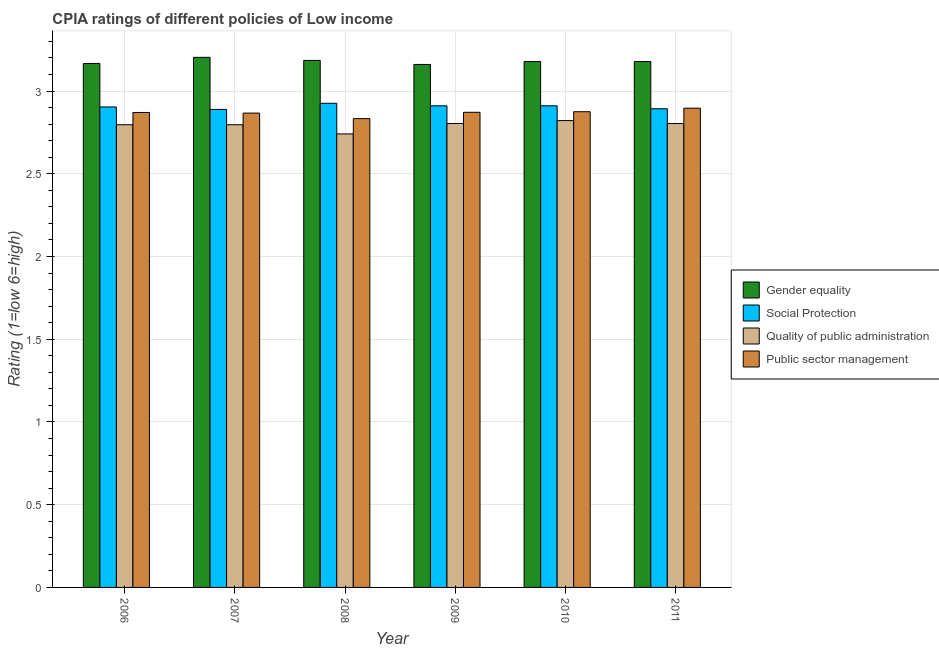Are the number of bars per tick equal to the number of legend labels?
Keep it short and to the point. Yes. How many bars are there on the 6th tick from the right?
Provide a succinct answer. 4. What is the cpia rating of public sector management in 2007?
Offer a terse response. 2.87. Across all years, what is the maximum cpia rating of social protection?
Your answer should be compact. 2.93. Across all years, what is the minimum cpia rating of quality of public administration?
Offer a very short reply. 2.74. In which year was the cpia rating of gender equality minimum?
Offer a terse response. 2009. What is the total cpia rating of quality of public administration in the graph?
Your answer should be very brief. 16.76. What is the difference between the cpia rating of social protection in 2008 and that in 2010?
Make the answer very short. 0.02. What is the difference between the cpia rating of gender equality in 2008 and the cpia rating of quality of public administration in 2009?
Your answer should be compact. 0.02. What is the average cpia rating of public sector management per year?
Your response must be concise. 2.87. In the year 2010, what is the difference between the cpia rating of gender equality and cpia rating of quality of public administration?
Offer a terse response. 0. What is the ratio of the cpia rating of social protection in 2008 to that in 2009?
Keep it short and to the point. 1.01. What is the difference between the highest and the second highest cpia rating of quality of public administration?
Provide a short and direct response. 0.02. What is the difference between the highest and the lowest cpia rating of quality of public administration?
Your response must be concise. 0.08. Is the sum of the cpia rating of gender equality in 2007 and 2009 greater than the maximum cpia rating of quality of public administration across all years?
Provide a succinct answer. Yes. What does the 1st bar from the left in 2010 represents?
Give a very brief answer. Gender equality. What does the 4th bar from the right in 2009 represents?
Make the answer very short. Gender equality. Is it the case that in every year, the sum of the cpia rating of gender equality and cpia rating of social protection is greater than the cpia rating of quality of public administration?
Offer a terse response. Yes. How many years are there in the graph?
Give a very brief answer. 6. Are the values on the major ticks of Y-axis written in scientific E-notation?
Ensure brevity in your answer.  No. How are the legend labels stacked?
Give a very brief answer. Vertical. What is the title of the graph?
Give a very brief answer. CPIA ratings of different policies of Low income. What is the label or title of the X-axis?
Your answer should be very brief. Year. What is the Rating (1=low 6=high) of Gender equality in 2006?
Make the answer very short. 3.17. What is the Rating (1=low 6=high) of Social Protection in 2006?
Keep it short and to the point. 2.9. What is the Rating (1=low 6=high) of Quality of public administration in 2006?
Keep it short and to the point. 2.8. What is the Rating (1=low 6=high) of Public sector management in 2006?
Your answer should be very brief. 2.87. What is the Rating (1=low 6=high) of Gender equality in 2007?
Give a very brief answer. 3.2. What is the Rating (1=low 6=high) of Social Protection in 2007?
Ensure brevity in your answer.  2.89. What is the Rating (1=low 6=high) of Quality of public administration in 2007?
Provide a succinct answer. 2.8. What is the Rating (1=low 6=high) in Public sector management in 2007?
Keep it short and to the point. 2.87. What is the Rating (1=low 6=high) in Gender equality in 2008?
Offer a terse response. 3.19. What is the Rating (1=low 6=high) of Social Protection in 2008?
Offer a terse response. 2.93. What is the Rating (1=low 6=high) of Quality of public administration in 2008?
Your answer should be very brief. 2.74. What is the Rating (1=low 6=high) in Public sector management in 2008?
Keep it short and to the point. 2.83. What is the Rating (1=low 6=high) in Gender equality in 2009?
Make the answer very short. 3.16. What is the Rating (1=low 6=high) of Social Protection in 2009?
Offer a terse response. 2.91. What is the Rating (1=low 6=high) in Quality of public administration in 2009?
Your answer should be compact. 2.8. What is the Rating (1=low 6=high) of Public sector management in 2009?
Offer a terse response. 2.87. What is the Rating (1=low 6=high) in Gender equality in 2010?
Your response must be concise. 3.18. What is the Rating (1=low 6=high) in Social Protection in 2010?
Offer a terse response. 2.91. What is the Rating (1=low 6=high) in Quality of public administration in 2010?
Make the answer very short. 2.82. What is the Rating (1=low 6=high) of Public sector management in 2010?
Your response must be concise. 2.88. What is the Rating (1=low 6=high) in Gender equality in 2011?
Your answer should be very brief. 3.18. What is the Rating (1=low 6=high) of Social Protection in 2011?
Your answer should be very brief. 2.89. What is the Rating (1=low 6=high) of Quality of public administration in 2011?
Provide a short and direct response. 2.8. What is the Rating (1=low 6=high) of Public sector management in 2011?
Make the answer very short. 2.9. Across all years, what is the maximum Rating (1=low 6=high) of Gender equality?
Ensure brevity in your answer.  3.2. Across all years, what is the maximum Rating (1=low 6=high) in Social Protection?
Make the answer very short. 2.93. Across all years, what is the maximum Rating (1=low 6=high) in Quality of public administration?
Offer a very short reply. 2.82. Across all years, what is the maximum Rating (1=low 6=high) in Public sector management?
Offer a terse response. 2.9. Across all years, what is the minimum Rating (1=low 6=high) in Gender equality?
Make the answer very short. 3.16. Across all years, what is the minimum Rating (1=low 6=high) of Social Protection?
Your answer should be compact. 2.89. Across all years, what is the minimum Rating (1=low 6=high) of Quality of public administration?
Keep it short and to the point. 2.74. Across all years, what is the minimum Rating (1=low 6=high) in Public sector management?
Give a very brief answer. 2.83. What is the total Rating (1=low 6=high) in Gender equality in the graph?
Your answer should be compact. 19.07. What is the total Rating (1=low 6=high) of Social Protection in the graph?
Your answer should be compact. 17.43. What is the total Rating (1=low 6=high) of Quality of public administration in the graph?
Provide a short and direct response. 16.76. What is the total Rating (1=low 6=high) of Public sector management in the graph?
Offer a very short reply. 17.21. What is the difference between the Rating (1=low 6=high) in Gender equality in 2006 and that in 2007?
Ensure brevity in your answer.  -0.04. What is the difference between the Rating (1=low 6=high) in Social Protection in 2006 and that in 2007?
Offer a terse response. 0.01. What is the difference between the Rating (1=low 6=high) in Public sector management in 2006 and that in 2007?
Your answer should be compact. 0. What is the difference between the Rating (1=low 6=high) of Gender equality in 2006 and that in 2008?
Your answer should be compact. -0.02. What is the difference between the Rating (1=low 6=high) in Social Protection in 2006 and that in 2008?
Keep it short and to the point. -0.02. What is the difference between the Rating (1=low 6=high) in Quality of public administration in 2006 and that in 2008?
Offer a very short reply. 0.06. What is the difference between the Rating (1=low 6=high) in Public sector management in 2006 and that in 2008?
Offer a terse response. 0.04. What is the difference between the Rating (1=low 6=high) of Gender equality in 2006 and that in 2009?
Keep it short and to the point. 0.01. What is the difference between the Rating (1=low 6=high) of Social Protection in 2006 and that in 2009?
Offer a very short reply. -0.01. What is the difference between the Rating (1=low 6=high) in Quality of public administration in 2006 and that in 2009?
Ensure brevity in your answer.  -0.01. What is the difference between the Rating (1=low 6=high) in Public sector management in 2006 and that in 2009?
Your answer should be compact. -0. What is the difference between the Rating (1=low 6=high) of Gender equality in 2006 and that in 2010?
Provide a succinct answer. -0.01. What is the difference between the Rating (1=low 6=high) in Social Protection in 2006 and that in 2010?
Ensure brevity in your answer.  -0.01. What is the difference between the Rating (1=low 6=high) in Quality of public administration in 2006 and that in 2010?
Your answer should be compact. -0.03. What is the difference between the Rating (1=low 6=high) in Public sector management in 2006 and that in 2010?
Make the answer very short. -0. What is the difference between the Rating (1=low 6=high) in Gender equality in 2006 and that in 2011?
Your response must be concise. -0.01. What is the difference between the Rating (1=low 6=high) of Social Protection in 2006 and that in 2011?
Keep it short and to the point. 0.01. What is the difference between the Rating (1=low 6=high) of Quality of public administration in 2006 and that in 2011?
Offer a very short reply. -0.01. What is the difference between the Rating (1=low 6=high) in Public sector management in 2006 and that in 2011?
Keep it short and to the point. -0.03. What is the difference between the Rating (1=low 6=high) of Gender equality in 2007 and that in 2008?
Provide a short and direct response. 0.02. What is the difference between the Rating (1=low 6=high) of Social Protection in 2007 and that in 2008?
Offer a terse response. -0.04. What is the difference between the Rating (1=low 6=high) of Quality of public administration in 2007 and that in 2008?
Your response must be concise. 0.06. What is the difference between the Rating (1=low 6=high) of Public sector management in 2007 and that in 2008?
Your answer should be compact. 0.03. What is the difference between the Rating (1=low 6=high) of Gender equality in 2007 and that in 2009?
Ensure brevity in your answer.  0.04. What is the difference between the Rating (1=low 6=high) in Social Protection in 2007 and that in 2009?
Your answer should be compact. -0.02. What is the difference between the Rating (1=low 6=high) in Quality of public administration in 2007 and that in 2009?
Offer a terse response. -0.01. What is the difference between the Rating (1=low 6=high) in Public sector management in 2007 and that in 2009?
Offer a terse response. -0. What is the difference between the Rating (1=low 6=high) in Gender equality in 2007 and that in 2010?
Give a very brief answer. 0.03. What is the difference between the Rating (1=low 6=high) of Social Protection in 2007 and that in 2010?
Make the answer very short. -0.02. What is the difference between the Rating (1=low 6=high) in Quality of public administration in 2007 and that in 2010?
Offer a very short reply. -0.03. What is the difference between the Rating (1=low 6=high) in Public sector management in 2007 and that in 2010?
Make the answer very short. -0.01. What is the difference between the Rating (1=low 6=high) in Gender equality in 2007 and that in 2011?
Provide a succinct answer. 0.03. What is the difference between the Rating (1=low 6=high) in Social Protection in 2007 and that in 2011?
Your answer should be compact. -0. What is the difference between the Rating (1=low 6=high) of Quality of public administration in 2007 and that in 2011?
Give a very brief answer. -0.01. What is the difference between the Rating (1=low 6=high) of Public sector management in 2007 and that in 2011?
Provide a succinct answer. -0.03. What is the difference between the Rating (1=low 6=high) in Gender equality in 2008 and that in 2009?
Offer a very short reply. 0.02. What is the difference between the Rating (1=low 6=high) of Social Protection in 2008 and that in 2009?
Your answer should be very brief. 0.02. What is the difference between the Rating (1=low 6=high) in Quality of public administration in 2008 and that in 2009?
Make the answer very short. -0.06. What is the difference between the Rating (1=low 6=high) of Public sector management in 2008 and that in 2009?
Provide a short and direct response. -0.04. What is the difference between the Rating (1=low 6=high) in Gender equality in 2008 and that in 2010?
Make the answer very short. 0.01. What is the difference between the Rating (1=low 6=high) in Social Protection in 2008 and that in 2010?
Give a very brief answer. 0.02. What is the difference between the Rating (1=low 6=high) of Quality of public administration in 2008 and that in 2010?
Your answer should be compact. -0.08. What is the difference between the Rating (1=low 6=high) in Public sector management in 2008 and that in 2010?
Your answer should be compact. -0.04. What is the difference between the Rating (1=low 6=high) in Gender equality in 2008 and that in 2011?
Ensure brevity in your answer.  0.01. What is the difference between the Rating (1=low 6=high) in Social Protection in 2008 and that in 2011?
Your answer should be compact. 0.03. What is the difference between the Rating (1=low 6=high) of Quality of public administration in 2008 and that in 2011?
Your answer should be compact. -0.06. What is the difference between the Rating (1=low 6=high) in Public sector management in 2008 and that in 2011?
Make the answer very short. -0.06. What is the difference between the Rating (1=low 6=high) of Gender equality in 2009 and that in 2010?
Give a very brief answer. -0.02. What is the difference between the Rating (1=low 6=high) of Social Protection in 2009 and that in 2010?
Your response must be concise. 0. What is the difference between the Rating (1=low 6=high) of Quality of public administration in 2009 and that in 2010?
Offer a terse response. -0.02. What is the difference between the Rating (1=low 6=high) of Public sector management in 2009 and that in 2010?
Make the answer very short. -0. What is the difference between the Rating (1=low 6=high) of Gender equality in 2009 and that in 2011?
Your answer should be compact. -0.02. What is the difference between the Rating (1=low 6=high) in Social Protection in 2009 and that in 2011?
Your response must be concise. 0.02. What is the difference between the Rating (1=low 6=high) of Quality of public administration in 2009 and that in 2011?
Your response must be concise. 0. What is the difference between the Rating (1=low 6=high) of Public sector management in 2009 and that in 2011?
Make the answer very short. -0.03. What is the difference between the Rating (1=low 6=high) of Social Protection in 2010 and that in 2011?
Provide a succinct answer. 0.02. What is the difference between the Rating (1=low 6=high) of Quality of public administration in 2010 and that in 2011?
Ensure brevity in your answer.  0.02. What is the difference between the Rating (1=low 6=high) in Public sector management in 2010 and that in 2011?
Offer a terse response. -0.02. What is the difference between the Rating (1=low 6=high) in Gender equality in 2006 and the Rating (1=low 6=high) in Social Protection in 2007?
Provide a succinct answer. 0.28. What is the difference between the Rating (1=low 6=high) in Gender equality in 2006 and the Rating (1=low 6=high) in Quality of public administration in 2007?
Your answer should be very brief. 0.37. What is the difference between the Rating (1=low 6=high) of Gender equality in 2006 and the Rating (1=low 6=high) of Public sector management in 2007?
Ensure brevity in your answer.  0.3. What is the difference between the Rating (1=low 6=high) in Social Protection in 2006 and the Rating (1=low 6=high) in Quality of public administration in 2007?
Ensure brevity in your answer.  0.11. What is the difference between the Rating (1=low 6=high) of Social Protection in 2006 and the Rating (1=low 6=high) of Public sector management in 2007?
Give a very brief answer. 0.04. What is the difference between the Rating (1=low 6=high) of Quality of public administration in 2006 and the Rating (1=low 6=high) of Public sector management in 2007?
Provide a succinct answer. -0.07. What is the difference between the Rating (1=low 6=high) of Gender equality in 2006 and the Rating (1=low 6=high) of Social Protection in 2008?
Offer a very short reply. 0.24. What is the difference between the Rating (1=low 6=high) in Gender equality in 2006 and the Rating (1=low 6=high) in Quality of public administration in 2008?
Keep it short and to the point. 0.43. What is the difference between the Rating (1=low 6=high) of Gender equality in 2006 and the Rating (1=low 6=high) of Public sector management in 2008?
Make the answer very short. 0.33. What is the difference between the Rating (1=low 6=high) in Social Protection in 2006 and the Rating (1=low 6=high) in Quality of public administration in 2008?
Offer a terse response. 0.16. What is the difference between the Rating (1=low 6=high) in Social Protection in 2006 and the Rating (1=low 6=high) in Public sector management in 2008?
Offer a terse response. 0.07. What is the difference between the Rating (1=low 6=high) in Quality of public administration in 2006 and the Rating (1=low 6=high) in Public sector management in 2008?
Make the answer very short. -0.04. What is the difference between the Rating (1=low 6=high) of Gender equality in 2006 and the Rating (1=low 6=high) of Social Protection in 2009?
Your answer should be very brief. 0.26. What is the difference between the Rating (1=low 6=high) in Gender equality in 2006 and the Rating (1=low 6=high) in Quality of public administration in 2009?
Keep it short and to the point. 0.36. What is the difference between the Rating (1=low 6=high) of Gender equality in 2006 and the Rating (1=low 6=high) of Public sector management in 2009?
Keep it short and to the point. 0.3. What is the difference between the Rating (1=low 6=high) in Social Protection in 2006 and the Rating (1=low 6=high) in Quality of public administration in 2009?
Give a very brief answer. 0.1. What is the difference between the Rating (1=low 6=high) of Social Protection in 2006 and the Rating (1=low 6=high) of Public sector management in 2009?
Ensure brevity in your answer.  0.03. What is the difference between the Rating (1=low 6=high) of Quality of public administration in 2006 and the Rating (1=low 6=high) of Public sector management in 2009?
Provide a short and direct response. -0.08. What is the difference between the Rating (1=low 6=high) of Gender equality in 2006 and the Rating (1=low 6=high) of Social Protection in 2010?
Your response must be concise. 0.26. What is the difference between the Rating (1=low 6=high) of Gender equality in 2006 and the Rating (1=low 6=high) of Quality of public administration in 2010?
Ensure brevity in your answer.  0.35. What is the difference between the Rating (1=low 6=high) of Gender equality in 2006 and the Rating (1=low 6=high) of Public sector management in 2010?
Make the answer very short. 0.29. What is the difference between the Rating (1=low 6=high) of Social Protection in 2006 and the Rating (1=low 6=high) of Quality of public administration in 2010?
Offer a terse response. 0.08. What is the difference between the Rating (1=low 6=high) in Social Protection in 2006 and the Rating (1=low 6=high) in Public sector management in 2010?
Your response must be concise. 0.03. What is the difference between the Rating (1=low 6=high) in Quality of public administration in 2006 and the Rating (1=low 6=high) in Public sector management in 2010?
Make the answer very short. -0.08. What is the difference between the Rating (1=low 6=high) of Gender equality in 2006 and the Rating (1=low 6=high) of Social Protection in 2011?
Ensure brevity in your answer.  0.27. What is the difference between the Rating (1=low 6=high) in Gender equality in 2006 and the Rating (1=low 6=high) in Quality of public administration in 2011?
Ensure brevity in your answer.  0.36. What is the difference between the Rating (1=low 6=high) in Gender equality in 2006 and the Rating (1=low 6=high) in Public sector management in 2011?
Your answer should be compact. 0.27. What is the difference between the Rating (1=low 6=high) in Social Protection in 2006 and the Rating (1=low 6=high) in Quality of public administration in 2011?
Your response must be concise. 0.1. What is the difference between the Rating (1=low 6=high) in Social Protection in 2006 and the Rating (1=low 6=high) in Public sector management in 2011?
Provide a succinct answer. 0.01. What is the difference between the Rating (1=low 6=high) of Quality of public administration in 2006 and the Rating (1=low 6=high) of Public sector management in 2011?
Your answer should be very brief. -0.1. What is the difference between the Rating (1=low 6=high) in Gender equality in 2007 and the Rating (1=low 6=high) in Social Protection in 2008?
Offer a very short reply. 0.28. What is the difference between the Rating (1=low 6=high) of Gender equality in 2007 and the Rating (1=low 6=high) of Quality of public administration in 2008?
Provide a succinct answer. 0.46. What is the difference between the Rating (1=low 6=high) of Gender equality in 2007 and the Rating (1=low 6=high) of Public sector management in 2008?
Provide a short and direct response. 0.37. What is the difference between the Rating (1=low 6=high) in Social Protection in 2007 and the Rating (1=low 6=high) in Quality of public administration in 2008?
Give a very brief answer. 0.15. What is the difference between the Rating (1=low 6=high) of Social Protection in 2007 and the Rating (1=low 6=high) of Public sector management in 2008?
Provide a succinct answer. 0.06. What is the difference between the Rating (1=low 6=high) in Quality of public administration in 2007 and the Rating (1=low 6=high) in Public sector management in 2008?
Provide a succinct answer. -0.04. What is the difference between the Rating (1=low 6=high) of Gender equality in 2007 and the Rating (1=low 6=high) of Social Protection in 2009?
Give a very brief answer. 0.29. What is the difference between the Rating (1=low 6=high) of Gender equality in 2007 and the Rating (1=low 6=high) of Quality of public administration in 2009?
Keep it short and to the point. 0.4. What is the difference between the Rating (1=low 6=high) in Gender equality in 2007 and the Rating (1=low 6=high) in Public sector management in 2009?
Offer a terse response. 0.33. What is the difference between the Rating (1=low 6=high) in Social Protection in 2007 and the Rating (1=low 6=high) in Quality of public administration in 2009?
Provide a succinct answer. 0.09. What is the difference between the Rating (1=low 6=high) of Social Protection in 2007 and the Rating (1=low 6=high) of Public sector management in 2009?
Your answer should be very brief. 0.02. What is the difference between the Rating (1=low 6=high) in Quality of public administration in 2007 and the Rating (1=low 6=high) in Public sector management in 2009?
Your response must be concise. -0.08. What is the difference between the Rating (1=low 6=high) of Gender equality in 2007 and the Rating (1=low 6=high) of Social Protection in 2010?
Keep it short and to the point. 0.29. What is the difference between the Rating (1=low 6=high) in Gender equality in 2007 and the Rating (1=low 6=high) in Quality of public administration in 2010?
Your answer should be compact. 0.38. What is the difference between the Rating (1=low 6=high) of Gender equality in 2007 and the Rating (1=low 6=high) of Public sector management in 2010?
Your answer should be compact. 0.33. What is the difference between the Rating (1=low 6=high) in Social Protection in 2007 and the Rating (1=low 6=high) in Quality of public administration in 2010?
Offer a terse response. 0.07. What is the difference between the Rating (1=low 6=high) in Social Protection in 2007 and the Rating (1=low 6=high) in Public sector management in 2010?
Offer a terse response. 0.01. What is the difference between the Rating (1=low 6=high) in Quality of public administration in 2007 and the Rating (1=low 6=high) in Public sector management in 2010?
Your answer should be compact. -0.08. What is the difference between the Rating (1=low 6=high) in Gender equality in 2007 and the Rating (1=low 6=high) in Social Protection in 2011?
Ensure brevity in your answer.  0.31. What is the difference between the Rating (1=low 6=high) of Gender equality in 2007 and the Rating (1=low 6=high) of Quality of public administration in 2011?
Keep it short and to the point. 0.4. What is the difference between the Rating (1=low 6=high) of Gender equality in 2007 and the Rating (1=low 6=high) of Public sector management in 2011?
Provide a succinct answer. 0.31. What is the difference between the Rating (1=low 6=high) of Social Protection in 2007 and the Rating (1=low 6=high) of Quality of public administration in 2011?
Keep it short and to the point. 0.09. What is the difference between the Rating (1=low 6=high) of Social Protection in 2007 and the Rating (1=low 6=high) of Public sector management in 2011?
Provide a short and direct response. -0.01. What is the difference between the Rating (1=low 6=high) in Quality of public administration in 2007 and the Rating (1=low 6=high) in Public sector management in 2011?
Provide a short and direct response. -0.1. What is the difference between the Rating (1=low 6=high) of Gender equality in 2008 and the Rating (1=low 6=high) of Social Protection in 2009?
Offer a terse response. 0.27. What is the difference between the Rating (1=low 6=high) in Gender equality in 2008 and the Rating (1=low 6=high) in Quality of public administration in 2009?
Provide a succinct answer. 0.38. What is the difference between the Rating (1=low 6=high) of Gender equality in 2008 and the Rating (1=low 6=high) of Public sector management in 2009?
Keep it short and to the point. 0.31. What is the difference between the Rating (1=low 6=high) of Social Protection in 2008 and the Rating (1=low 6=high) of Quality of public administration in 2009?
Your response must be concise. 0.12. What is the difference between the Rating (1=low 6=high) in Social Protection in 2008 and the Rating (1=low 6=high) in Public sector management in 2009?
Provide a short and direct response. 0.05. What is the difference between the Rating (1=low 6=high) in Quality of public administration in 2008 and the Rating (1=low 6=high) in Public sector management in 2009?
Give a very brief answer. -0.13. What is the difference between the Rating (1=low 6=high) of Gender equality in 2008 and the Rating (1=low 6=high) of Social Protection in 2010?
Keep it short and to the point. 0.27. What is the difference between the Rating (1=low 6=high) in Gender equality in 2008 and the Rating (1=low 6=high) in Quality of public administration in 2010?
Offer a very short reply. 0.36. What is the difference between the Rating (1=low 6=high) in Gender equality in 2008 and the Rating (1=low 6=high) in Public sector management in 2010?
Provide a short and direct response. 0.31. What is the difference between the Rating (1=low 6=high) of Social Protection in 2008 and the Rating (1=low 6=high) of Quality of public administration in 2010?
Offer a very short reply. 0.1. What is the difference between the Rating (1=low 6=high) in Social Protection in 2008 and the Rating (1=low 6=high) in Public sector management in 2010?
Ensure brevity in your answer.  0.05. What is the difference between the Rating (1=low 6=high) in Quality of public administration in 2008 and the Rating (1=low 6=high) in Public sector management in 2010?
Provide a short and direct response. -0.13. What is the difference between the Rating (1=low 6=high) of Gender equality in 2008 and the Rating (1=low 6=high) of Social Protection in 2011?
Offer a very short reply. 0.29. What is the difference between the Rating (1=low 6=high) of Gender equality in 2008 and the Rating (1=low 6=high) of Quality of public administration in 2011?
Make the answer very short. 0.38. What is the difference between the Rating (1=low 6=high) in Gender equality in 2008 and the Rating (1=low 6=high) in Public sector management in 2011?
Offer a terse response. 0.29. What is the difference between the Rating (1=low 6=high) of Social Protection in 2008 and the Rating (1=low 6=high) of Quality of public administration in 2011?
Give a very brief answer. 0.12. What is the difference between the Rating (1=low 6=high) in Social Protection in 2008 and the Rating (1=low 6=high) in Public sector management in 2011?
Your answer should be compact. 0.03. What is the difference between the Rating (1=low 6=high) in Quality of public administration in 2008 and the Rating (1=low 6=high) in Public sector management in 2011?
Keep it short and to the point. -0.16. What is the difference between the Rating (1=low 6=high) of Gender equality in 2009 and the Rating (1=low 6=high) of Social Protection in 2010?
Offer a terse response. 0.25. What is the difference between the Rating (1=low 6=high) in Gender equality in 2009 and the Rating (1=low 6=high) in Quality of public administration in 2010?
Make the answer very short. 0.34. What is the difference between the Rating (1=low 6=high) in Gender equality in 2009 and the Rating (1=low 6=high) in Public sector management in 2010?
Offer a terse response. 0.29. What is the difference between the Rating (1=low 6=high) in Social Protection in 2009 and the Rating (1=low 6=high) in Quality of public administration in 2010?
Your answer should be compact. 0.09. What is the difference between the Rating (1=low 6=high) of Social Protection in 2009 and the Rating (1=low 6=high) of Public sector management in 2010?
Your answer should be very brief. 0.04. What is the difference between the Rating (1=low 6=high) in Quality of public administration in 2009 and the Rating (1=low 6=high) in Public sector management in 2010?
Offer a very short reply. -0.07. What is the difference between the Rating (1=low 6=high) in Gender equality in 2009 and the Rating (1=low 6=high) in Social Protection in 2011?
Give a very brief answer. 0.27. What is the difference between the Rating (1=low 6=high) in Gender equality in 2009 and the Rating (1=low 6=high) in Quality of public administration in 2011?
Ensure brevity in your answer.  0.36. What is the difference between the Rating (1=low 6=high) of Gender equality in 2009 and the Rating (1=low 6=high) of Public sector management in 2011?
Offer a terse response. 0.26. What is the difference between the Rating (1=low 6=high) of Social Protection in 2009 and the Rating (1=low 6=high) of Quality of public administration in 2011?
Give a very brief answer. 0.11. What is the difference between the Rating (1=low 6=high) in Social Protection in 2009 and the Rating (1=low 6=high) in Public sector management in 2011?
Offer a very short reply. 0.01. What is the difference between the Rating (1=low 6=high) of Quality of public administration in 2009 and the Rating (1=low 6=high) of Public sector management in 2011?
Offer a very short reply. -0.09. What is the difference between the Rating (1=low 6=high) of Gender equality in 2010 and the Rating (1=low 6=high) of Social Protection in 2011?
Give a very brief answer. 0.29. What is the difference between the Rating (1=low 6=high) in Gender equality in 2010 and the Rating (1=low 6=high) in Quality of public administration in 2011?
Offer a terse response. 0.38. What is the difference between the Rating (1=low 6=high) in Gender equality in 2010 and the Rating (1=low 6=high) in Public sector management in 2011?
Give a very brief answer. 0.28. What is the difference between the Rating (1=low 6=high) of Social Protection in 2010 and the Rating (1=low 6=high) of Quality of public administration in 2011?
Provide a short and direct response. 0.11. What is the difference between the Rating (1=low 6=high) in Social Protection in 2010 and the Rating (1=low 6=high) in Public sector management in 2011?
Your answer should be very brief. 0.01. What is the difference between the Rating (1=low 6=high) of Quality of public administration in 2010 and the Rating (1=low 6=high) of Public sector management in 2011?
Your response must be concise. -0.07. What is the average Rating (1=low 6=high) in Gender equality per year?
Your answer should be compact. 3.18. What is the average Rating (1=low 6=high) of Social Protection per year?
Ensure brevity in your answer.  2.91. What is the average Rating (1=low 6=high) in Quality of public administration per year?
Offer a terse response. 2.79. What is the average Rating (1=low 6=high) in Public sector management per year?
Give a very brief answer. 2.87. In the year 2006, what is the difference between the Rating (1=low 6=high) in Gender equality and Rating (1=low 6=high) in Social Protection?
Offer a terse response. 0.26. In the year 2006, what is the difference between the Rating (1=low 6=high) in Gender equality and Rating (1=low 6=high) in Quality of public administration?
Ensure brevity in your answer.  0.37. In the year 2006, what is the difference between the Rating (1=low 6=high) in Gender equality and Rating (1=low 6=high) in Public sector management?
Provide a succinct answer. 0.3. In the year 2006, what is the difference between the Rating (1=low 6=high) of Social Protection and Rating (1=low 6=high) of Quality of public administration?
Provide a short and direct response. 0.11. In the year 2006, what is the difference between the Rating (1=low 6=high) of Social Protection and Rating (1=low 6=high) of Public sector management?
Offer a very short reply. 0.03. In the year 2006, what is the difference between the Rating (1=low 6=high) in Quality of public administration and Rating (1=low 6=high) in Public sector management?
Make the answer very short. -0.07. In the year 2007, what is the difference between the Rating (1=low 6=high) in Gender equality and Rating (1=low 6=high) in Social Protection?
Provide a short and direct response. 0.31. In the year 2007, what is the difference between the Rating (1=low 6=high) of Gender equality and Rating (1=low 6=high) of Quality of public administration?
Your answer should be very brief. 0.41. In the year 2007, what is the difference between the Rating (1=low 6=high) in Gender equality and Rating (1=low 6=high) in Public sector management?
Your answer should be very brief. 0.34. In the year 2007, what is the difference between the Rating (1=low 6=high) of Social Protection and Rating (1=low 6=high) of Quality of public administration?
Ensure brevity in your answer.  0.09. In the year 2007, what is the difference between the Rating (1=low 6=high) of Social Protection and Rating (1=low 6=high) of Public sector management?
Give a very brief answer. 0.02. In the year 2007, what is the difference between the Rating (1=low 6=high) of Quality of public administration and Rating (1=low 6=high) of Public sector management?
Offer a very short reply. -0.07. In the year 2008, what is the difference between the Rating (1=low 6=high) in Gender equality and Rating (1=low 6=high) in Social Protection?
Make the answer very short. 0.26. In the year 2008, what is the difference between the Rating (1=low 6=high) in Gender equality and Rating (1=low 6=high) in Quality of public administration?
Your answer should be very brief. 0.44. In the year 2008, what is the difference between the Rating (1=low 6=high) of Gender equality and Rating (1=low 6=high) of Public sector management?
Give a very brief answer. 0.35. In the year 2008, what is the difference between the Rating (1=low 6=high) in Social Protection and Rating (1=low 6=high) in Quality of public administration?
Your answer should be compact. 0.19. In the year 2008, what is the difference between the Rating (1=low 6=high) of Social Protection and Rating (1=low 6=high) of Public sector management?
Offer a terse response. 0.09. In the year 2008, what is the difference between the Rating (1=low 6=high) of Quality of public administration and Rating (1=low 6=high) of Public sector management?
Your answer should be compact. -0.09. In the year 2009, what is the difference between the Rating (1=low 6=high) of Gender equality and Rating (1=low 6=high) of Social Protection?
Your response must be concise. 0.25. In the year 2009, what is the difference between the Rating (1=low 6=high) in Gender equality and Rating (1=low 6=high) in Quality of public administration?
Give a very brief answer. 0.36. In the year 2009, what is the difference between the Rating (1=low 6=high) in Gender equality and Rating (1=low 6=high) in Public sector management?
Offer a very short reply. 0.29. In the year 2009, what is the difference between the Rating (1=low 6=high) of Social Protection and Rating (1=low 6=high) of Quality of public administration?
Provide a succinct answer. 0.11. In the year 2009, what is the difference between the Rating (1=low 6=high) of Social Protection and Rating (1=low 6=high) of Public sector management?
Ensure brevity in your answer.  0.04. In the year 2009, what is the difference between the Rating (1=low 6=high) of Quality of public administration and Rating (1=low 6=high) of Public sector management?
Your response must be concise. -0.07. In the year 2010, what is the difference between the Rating (1=low 6=high) in Gender equality and Rating (1=low 6=high) in Social Protection?
Offer a very short reply. 0.27. In the year 2010, what is the difference between the Rating (1=low 6=high) in Gender equality and Rating (1=low 6=high) in Quality of public administration?
Provide a short and direct response. 0.36. In the year 2010, what is the difference between the Rating (1=low 6=high) in Gender equality and Rating (1=low 6=high) in Public sector management?
Your response must be concise. 0.3. In the year 2010, what is the difference between the Rating (1=low 6=high) of Social Protection and Rating (1=low 6=high) of Quality of public administration?
Provide a short and direct response. 0.09. In the year 2010, what is the difference between the Rating (1=low 6=high) of Social Protection and Rating (1=low 6=high) of Public sector management?
Offer a terse response. 0.04. In the year 2010, what is the difference between the Rating (1=low 6=high) in Quality of public administration and Rating (1=low 6=high) in Public sector management?
Give a very brief answer. -0.05. In the year 2011, what is the difference between the Rating (1=low 6=high) in Gender equality and Rating (1=low 6=high) in Social Protection?
Provide a short and direct response. 0.29. In the year 2011, what is the difference between the Rating (1=low 6=high) in Gender equality and Rating (1=low 6=high) in Quality of public administration?
Keep it short and to the point. 0.38. In the year 2011, what is the difference between the Rating (1=low 6=high) in Gender equality and Rating (1=low 6=high) in Public sector management?
Keep it short and to the point. 0.28. In the year 2011, what is the difference between the Rating (1=low 6=high) in Social Protection and Rating (1=low 6=high) in Quality of public administration?
Give a very brief answer. 0.09. In the year 2011, what is the difference between the Rating (1=low 6=high) of Social Protection and Rating (1=low 6=high) of Public sector management?
Your answer should be very brief. -0. In the year 2011, what is the difference between the Rating (1=low 6=high) in Quality of public administration and Rating (1=low 6=high) in Public sector management?
Provide a succinct answer. -0.09. What is the ratio of the Rating (1=low 6=high) of Gender equality in 2006 to that in 2007?
Provide a short and direct response. 0.99. What is the ratio of the Rating (1=low 6=high) of Social Protection in 2006 to that in 2007?
Give a very brief answer. 1.01. What is the ratio of the Rating (1=low 6=high) in Quality of public administration in 2006 to that in 2007?
Ensure brevity in your answer.  1. What is the ratio of the Rating (1=low 6=high) in Public sector management in 2006 to that in 2007?
Your response must be concise. 1. What is the ratio of the Rating (1=low 6=high) in Gender equality in 2006 to that in 2008?
Your response must be concise. 0.99. What is the ratio of the Rating (1=low 6=high) of Quality of public administration in 2006 to that in 2008?
Offer a very short reply. 1.02. What is the ratio of the Rating (1=low 6=high) in Public sector management in 2006 to that in 2008?
Give a very brief answer. 1.01. What is the ratio of the Rating (1=low 6=high) in Gender equality in 2006 to that in 2009?
Your answer should be compact. 1. What is the ratio of the Rating (1=low 6=high) of Social Protection in 2006 to that in 2009?
Your answer should be very brief. 1. What is the ratio of the Rating (1=low 6=high) in Quality of public administration in 2006 to that in 2009?
Make the answer very short. 1. What is the ratio of the Rating (1=low 6=high) of Public sector management in 2006 to that in 2009?
Provide a succinct answer. 1. What is the ratio of the Rating (1=low 6=high) of Gender equality in 2006 to that in 2010?
Your answer should be compact. 1. What is the ratio of the Rating (1=low 6=high) of Public sector management in 2006 to that in 2010?
Provide a succinct answer. 1. What is the ratio of the Rating (1=low 6=high) in Social Protection in 2006 to that in 2011?
Your answer should be compact. 1. What is the ratio of the Rating (1=low 6=high) in Quality of public administration in 2006 to that in 2011?
Provide a short and direct response. 1. What is the ratio of the Rating (1=low 6=high) in Public sector management in 2006 to that in 2011?
Keep it short and to the point. 0.99. What is the ratio of the Rating (1=low 6=high) of Gender equality in 2007 to that in 2008?
Ensure brevity in your answer.  1.01. What is the ratio of the Rating (1=low 6=high) in Social Protection in 2007 to that in 2008?
Offer a very short reply. 0.99. What is the ratio of the Rating (1=low 6=high) in Quality of public administration in 2007 to that in 2008?
Provide a short and direct response. 1.02. What is the ratio of the Rating (1=low 6=high) in Public sector management in 2007 to that in 2008?
Provide a short and direct response. 1.01. What is the ratio of the Rating (1=low 6=high) of Gender equality in 2007 to that in 2009?
Offer a terse response. 1.01. What is the ratio of the Rating (1=low 6=high) of Social Protection in 2007 to that in 2009?
Provide a short and direct response. 0.99. What is the ratio of the Rating (1=low 6=high) in Gender equality in 2007 to that in 2010?
Your answer should be compact. 1.01. What is the ratio of the Rating (1=low 6=high) in Social Protection in 2007 to that in 2010?
Ensure brevity in your answer.  0.99. What is the ratio of the Rating (1=low 6=high) in Quality of public administration in 2007 to that in 2010?
Provide a short and direct response. 0.99. What is the ratio of the Rating (1=low 6=high) of Gender equality in 2007 to that in 2011?
Offer a very short reply. 1.01. What is the ratio of the Rating (1=low 6=high) in Social Protection in 2007 to that in 2011?
Your answer should be compact. 1. What is the ratio of the Rating (1=low 6=high) in Quality of public administration in 2007 to that in 2011?
Provide a short and direct response. 1. What is the ratio of the Rating (1=low 6=high) in Public sector management in 2007 to that in 2011?
Provide a short and direct response. 0.99. What is the ratio of the Rating (1=low 6=high) in Gender equality in 2008 to that in 2009?
Your answer should be very brief. 1.01. What is the ratio of the Rating (1=low 6=high) in Social Protection in 2008 to that in 2009?
Ensure brevity in your answer.  1.01. What is the ratio of the Rating (1=low 6=high) in Quality of public administration in 2008 to that in 2009?
Your answer should be very brief. 0.98. What is the ratio of the Rating (1=low 6=high) of Public sector management in 2008 to that in 2009?
Offer a very short reply. 0.99. What is the ratio of the Rating (1=low 6=high) in Social Protection in 2008 to that in 2010?
Offer a very short reply. 1.01. What is the ratio of the Rating (1=low 6=high) of Quality of public administration in 2008 to that in 2010?
Provide a succinct answer. 0.97. What is the ratio of the Rating (1=low 6=high) in Public sector management in 2008 to that in 2010?
Give a very brief answer. 0.99. What is the ratio of the Rating (1=low 6=high) in Gender equality in 2008 to that in 2011?
Offer a very short reply. 1. What is the ratio of the Rating (1=low 6=high) in Social Protection in 2008 to that in 2011?
Your answer should be compact. 1.01. What is the ratio of the Rating (1=low 6=high) in Quality of public administration in 2008 to that in 2011?
Your answer should be compact. 0.98. What is the ratio of the Rating (1=low 6=high) in Public sector management in 2008 to that in 2011?
Your answer should be very brief. 0.98. What is the ratio of the Rating (1=low 6=high) of Gender equality in 2009 to that in 2010?
Provide a short and direct response. 0.99. What is the ratio of the Rating (1=low 6=high) in Public sector management in 2009 to that in 2010?
Your answer should be very brief. 1. What is the ratio of the Rating (1=low 6=high) of Gender equality in 2009 to that in 2011?
Make the answer very short. 0.99. What is the ratio of the Rating (1=low 6=high) in Public sector management in 2009 to that in 2011?
Your response must be concise. 0.99. What is the ratio of the Rating (1=low 6=high) in Quality of public administration in 2010 to that in 2011?
Offer a terse response. 1.01. What is the ratio of the Rating (1=low 6=high) in Public sector management in 2010 to that in 2011?
Offer a terse response. 0.99. What is the difference between the highest and the second highest Rating (1=low 6=high) of Gender equality?
Your answer should be very brief. 0.02. What is the difference between the highest and the second highest Rating (1=low 6=high) in Social Protection?
Provide a short and direct response. 0.02. What is the difference between the highest and the second highest Rating (1=low 6=high) in Quality of public administration?
Offer a terse response. 0.02. What is the difference between the highest and the second highest Rating (1=low 6=high) of Public sector management?
Your answer should be compact. 0.02. What is the difference between the highest and the lowest Rating (1=low 6=high) in Gender equality?
Make the answer very short. 0.04. What is the difference between the highest and the lowest Rating (1=low 6=high) of Social Protection?
Make the answer very short. 0.04. What is the difference between the highest and the lowest Rating (1=low 6=high) in Quality of public administration?
Offer a very short reply. 0.08. What is the difference between the highest and the lowest Rating (1=low 6=high) of Public sector management?
Your answer should be compact. 0.06. 